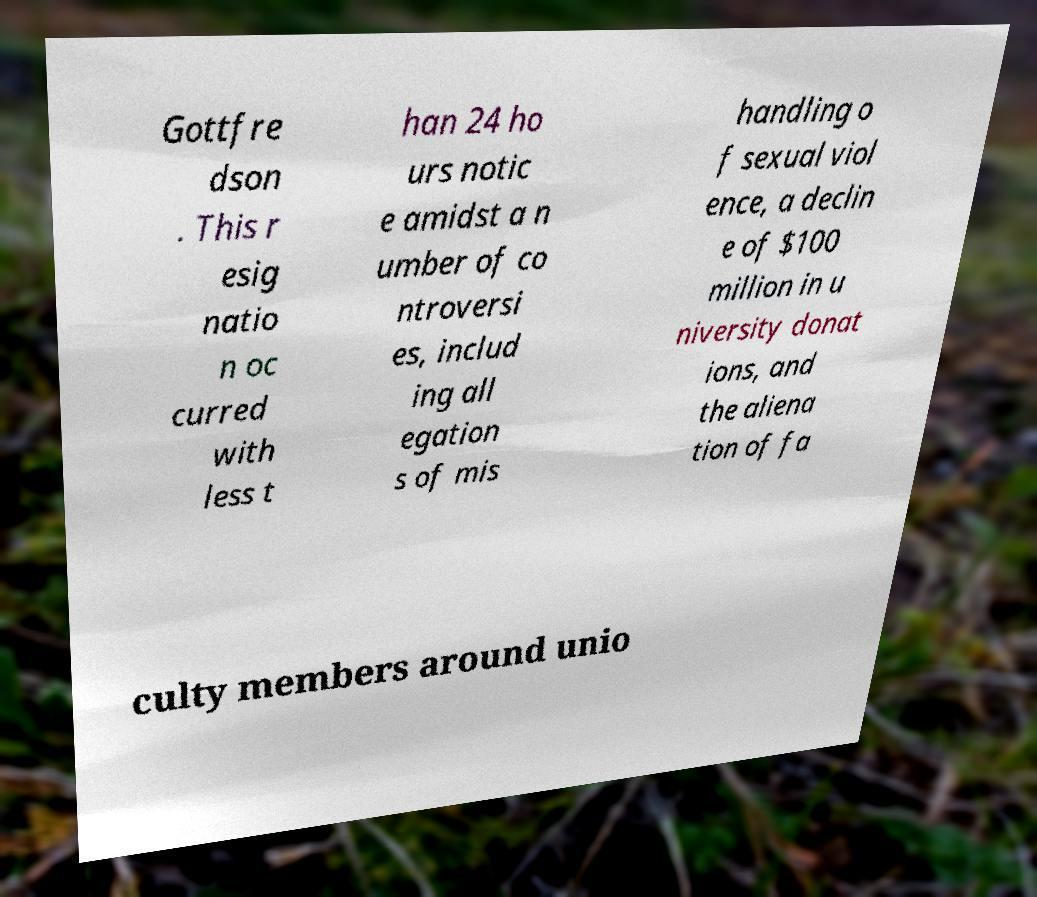I need the written content from this picture converted into text. Can you do that? Gottfre dson . This r esig natio n oc curred with less t han 24 ho urs notic e amidst a n umber of co ntroversi es, includ ing all egation s of mis handling o f sexual viol ence, a declin e of $100 million in u niversity donat ions, and the aliena tion of fa culty members around unio 